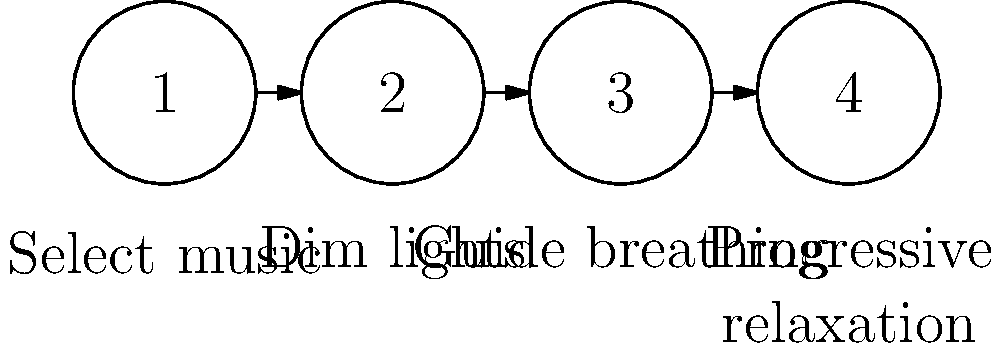Based on the illustration, what is the correct order of steps for implementing a music-based relaxation technique in a nursing setting? To determine the correct order of steps for implementing a music-based relaxation technique, let's analyze the illustration:

1. The first step (labeled "1") is associated with "Select music". This makes sense as the foundation of a music-based relaxation technique.

2. The second step (labeled "2") corresponds to "Dim lights". Creating a calm environment by adjusting lighting is a logical next step after selecting the music.

3. The third step (labeled "3") is linked to "Guide breathing". Once the environment is set, guiding the patient's breathing helps to initiate the relaxation process.

4. The final step (labeled "4") is associated with "Progressive relaxation". This technique, which involves tensing and relaxing muscle groups, is typically done after establishing a calm environment and controlled breathing.

The arrows between the steps indicate this is the intended sequence. This order follows a logical progression from setting up the environment to guiding the patient through increasingly focused relaxation techniques.
Answer: 1. Select music, 2. Dim lights, 3. Guide breathing, 4. Progressive relaxation 